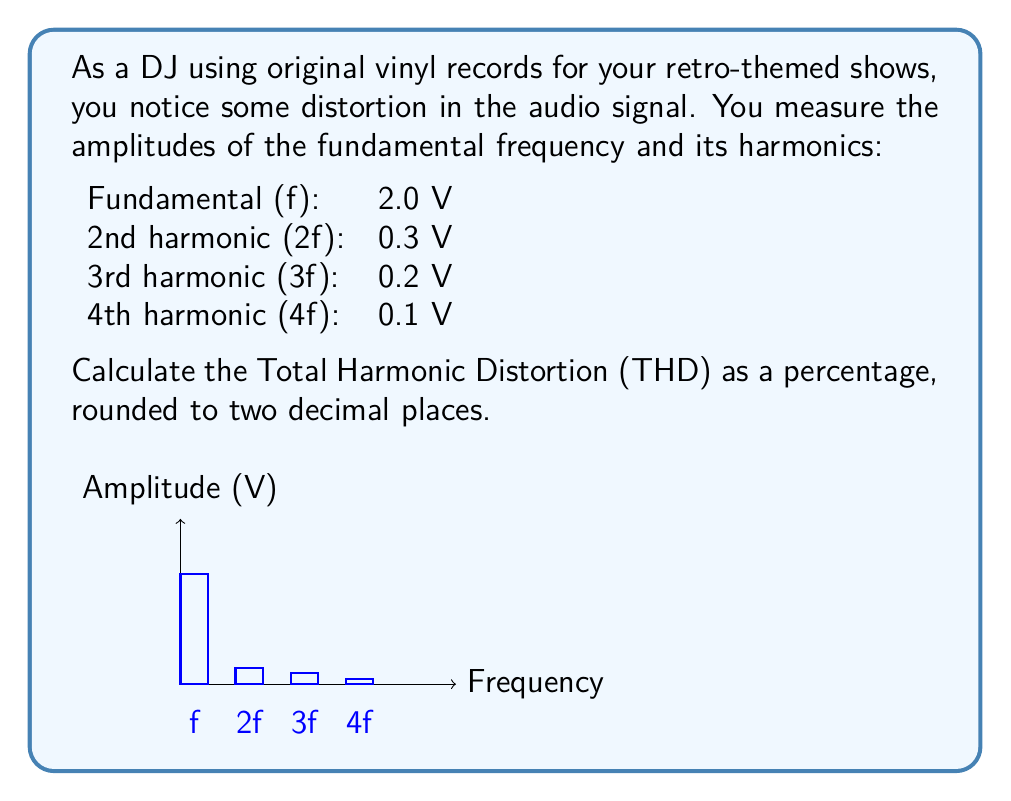Provide a solution to this math problem. To calculate the Total Harmonic Distortion (THD), we need to follow these steps:

1) The THD is defined as the ratio of the root mean square (RMS) of the harmonic components to the RMS of the fundamental frequency:

   $$ THD = \frac{\sqrt{V_2^2 + V_3^2 + V_4^2 + ...}}{V_1} \times 100\% $$

   Where $V_1$ is the amplitude of the fundamental frequency, and $V_2$, $V_3$, $V_4$, etc. are the amplitudes of the harmonics.

2) Let's substitute our values:
   $V_1 = 2.0$ V
   $V_2 = 0.3$ V
   $V_3 = 0.2$ V
   $V_4 = 0.1$ V

3) Calculate the numerator:
   $$ \sqrt{0.3^2 + 0.2^2 + 0.1^2} = \sqrt{0.09 + 0.04 + 0.01} = \sqrt{0.14} \approx 0.3742 $$

4) Now, we can calculate the THD:
   $$ THD = \frac{0.3742}{2.0} \times 100\% \approx 18.71\% $$

5) Rounding to two decimal places:
   $$ THD \approx 18.71\% $$
Answer: 18.71% 